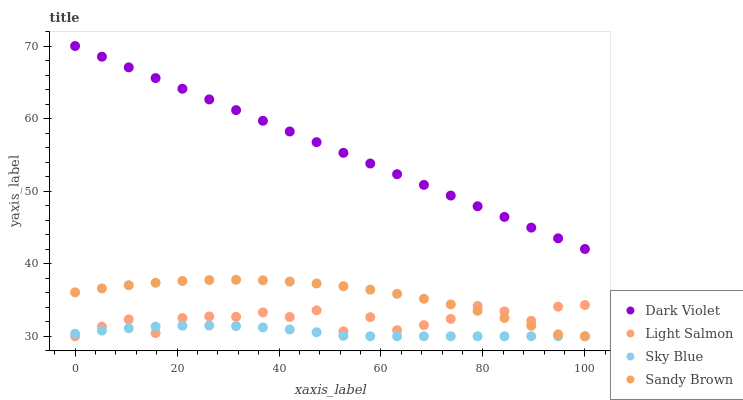Does Sky Blue have the minimum area under the curve?
Answer yes or no. Yes. Does Dark Violet have the maximum area under the curve?
Answer yes or no. Yes. Does Light Salmon have the minimum area under the curve?
Answer yes or no. No. Does Light Salmon have the maximum area under the curve?
Answer yes or no. No. Is Dark Violet the smoothest?
Answer yes or no. Yes. Is Light Salmon the roughest?
Answer yes or no. Yes. Is Sandy Brown the smoothest?
Answer yes or no. No. Is Sandy Brown the roughest?
Answer yes or no. No. Does Sky Blue have the lowest value?
Answer yes or no. Yes. Does Dark Violet have the lowest value?
Answer yes or no. No. Does Dark Violet have the highest value?
Answer yes or no. Yes. Does Light Salmon have the highest value?
Answer yes or no. No. Is Sky Blue less than Dark Violet?
Answer yes or no. Yes. Is Dark Violet greater than Light Salmon?
Answer yes or no. Yes. Does Light Salmon intersect Sky Blue?
Answer yes or no. Yes. Is Light Salmon less than Sky Blue?
Answer yes or no. No. Is Light Salmon greater than Sky Blue?
Answer yes or no. No. Does Sky Blue intersect Dark Violet?
Answer yes or no. No. 